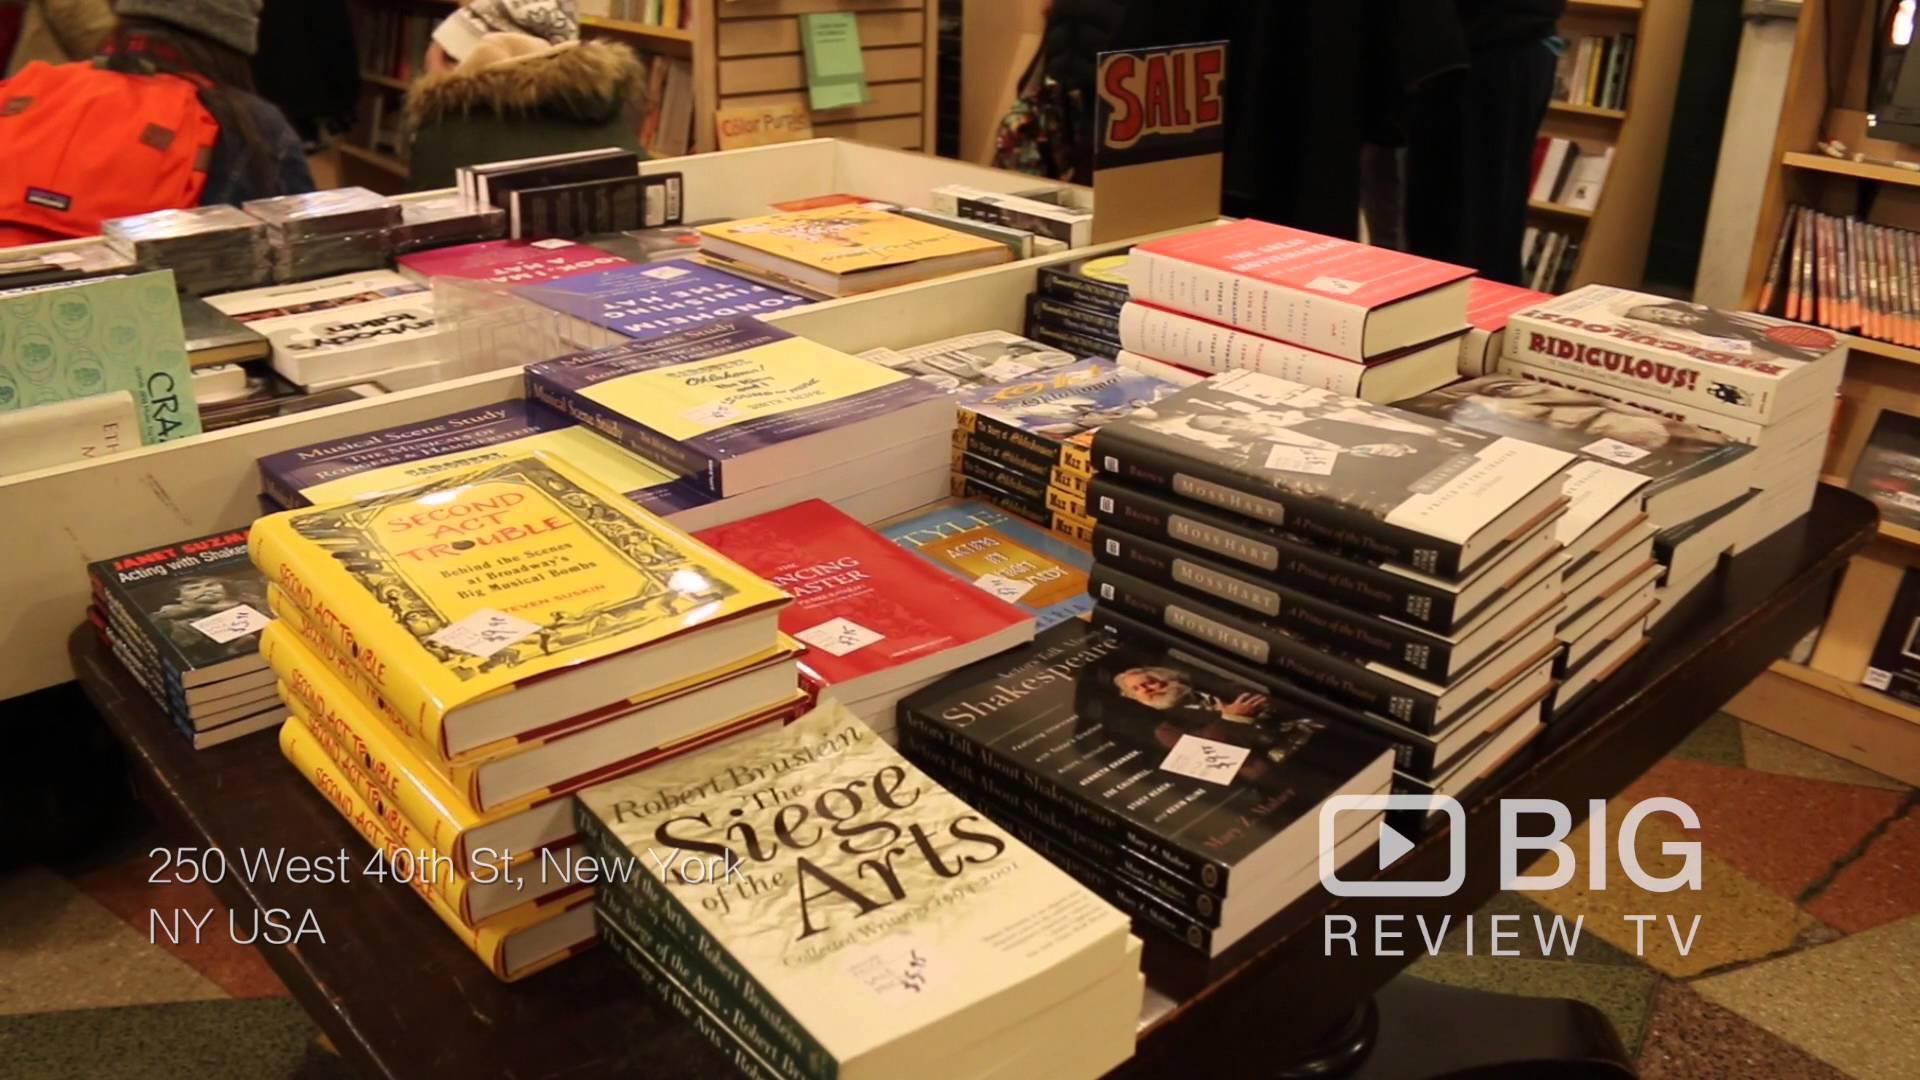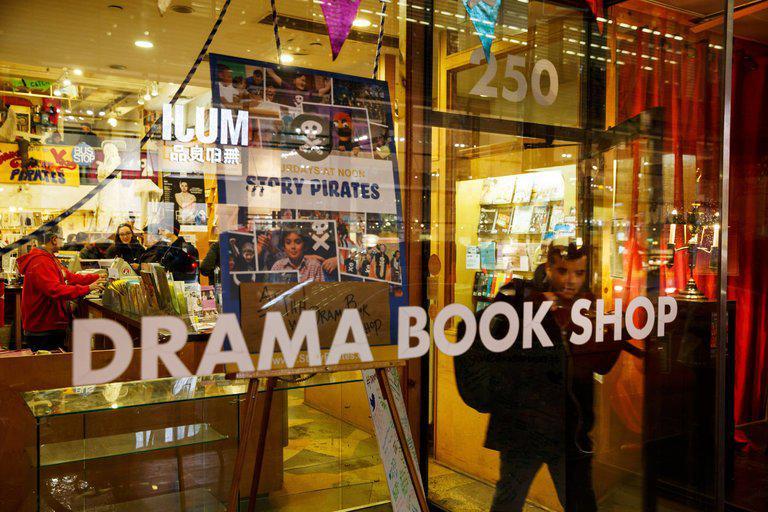The first image is the image on the left, the second image is the image on the right. Examine the images to the left and right. Is the description "An image shows the interior of a bookstore, with cluster of shoppers not behind glass." accurate? Answer yes or no. No. The first image is the image on the left, the second image is the image on the right. Analyze the images presented: Is the assertion "There are no people in the image on the left" valid? Answer yes or no. Yes. 